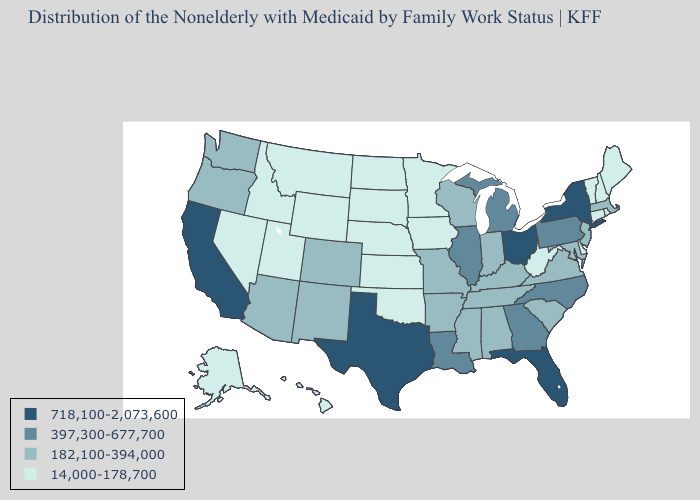What is the lowest value in the Northeast?
Concise answer only. 14,000-178,700. What is the value of Colorado?
Be succinct. 182,100-394,000. Which states hav the highest value in the MidWest?
Give a very brief answer. Ohio. Which states have the highest value in the USA?
Give a very brief answer. California, Florida, New York, Ohio, Texas. What is the lowest value in states that border Virginia?
Short answer required. 14,000-178,700. What is the highest value in the USA?
Short answer required. 718,100-2,073,600. Does Ohio have the highest value in the MidWest?
Answer briefly. Yes. Among the states that border Massachusetts , does Connecticut have the highest value?
Keep it brief. No. What is the lowest value in the MidWest?
Answer briefly. 14,000-178,700. What is the lowest value in the West?
Concise answer only. 14,000-178,700. Does Texas have the highest value in the USA?
Keep it brief. Yes. Is the legend a continuous bar?
Give a very brief answer. No. What is the value of Iowa?
Short answer required. 14,000-178,700. Is the legend a continuous bar?
Concise answer only. No. Name the states that have a value in the range 718,100-2,073,600?
Answer briefly. California, Florida, New York, Ohio, Texas. 